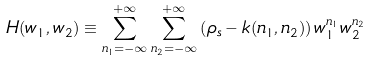Convert formula to latex. <formula><loc_0><loc_0><loc_500><loc_500>H ( w _ { 1 } , w _ { 2 } ) \equiv \sum _ { n _ { 1 } = - \infty } ^ { + \infty } \sum _ { n _ { 2 } = - \infty } ^ { + \infty } \left ( \rho _ { s } - k ( n _ { 1 } , n _ { 2 } ) \right ) w _ { 1 } ^ { n _ { 1 } } w _ { 2 } ^ { n _ { 2 } }</formula> 